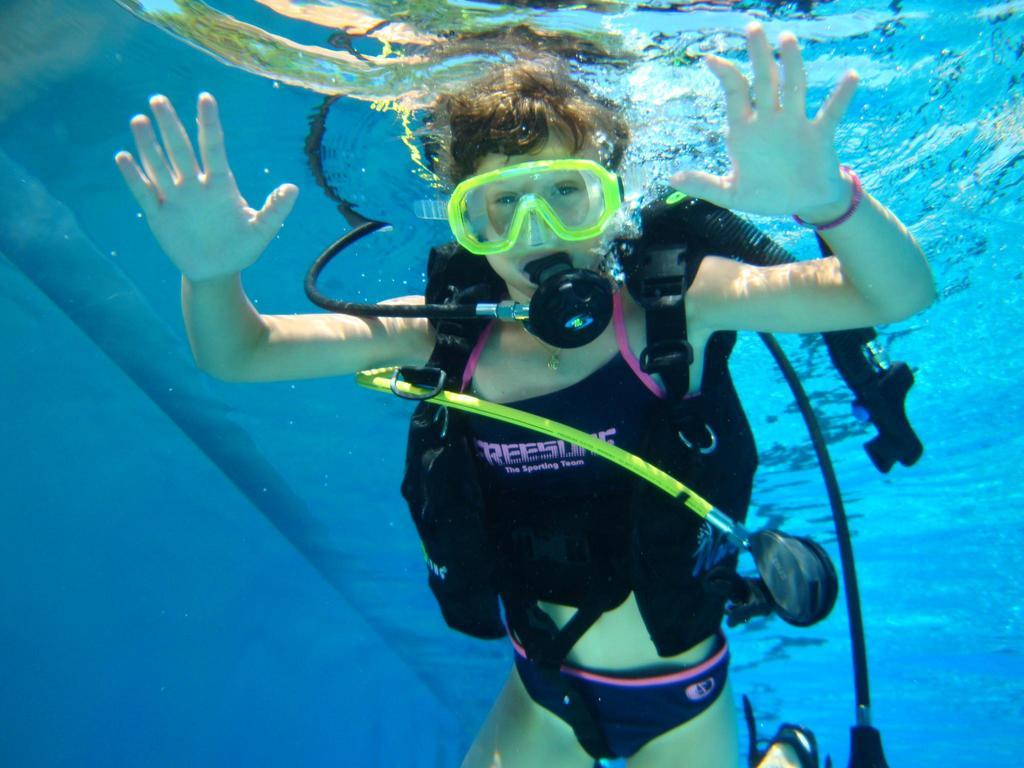What is the person in the image wearing on their face? The person is wearing a gas mask and swimming goggles in the image. What type of clothing is the person wearing? The person is wearing a swimming costume in the image. What activity is the person engaged in? The person is swimming in the water in the image. What type of curtain is hanging near the person in the image? There is no curtain present in the image. How many flies can be seen buzzing around the person in the image? There are no flies present in the image. 